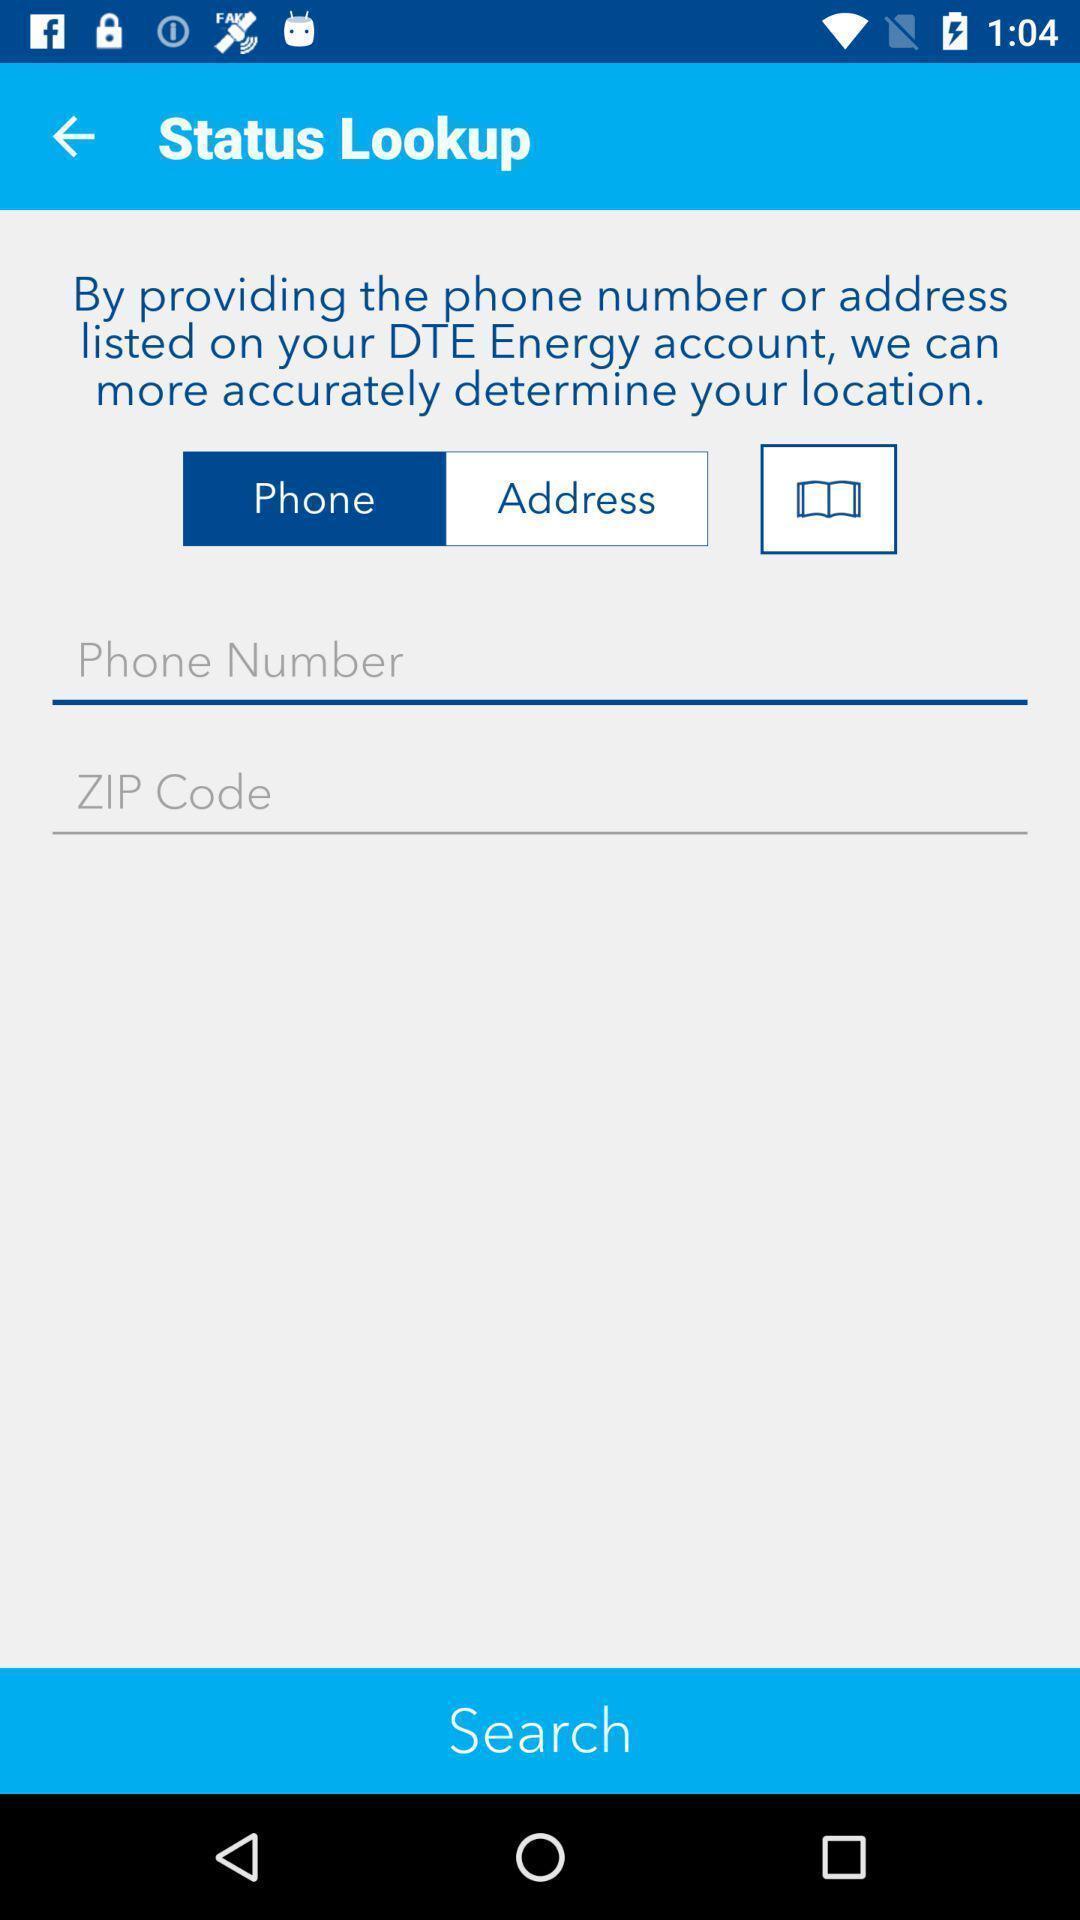Describe the content in this image. Page showing multiple fields to search. 